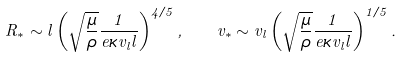<formula> <loc_0><loc_0><loc_500><loc_500>R _ { * } \sim l \left ( \sqrt { \frac { \mu } { \rho } } \frac { 1 } { e \kappa v _ { l } l } \right ) ^ { 4 / 5 } , \ \ v _ { * } \sim v _ { l } \left ( \sqrt { \frac { \mu } { \rho } } \frac { 1 } { e \kappa v _ { l } l } \right ) ^ { 1 / 5 } .</formula> 